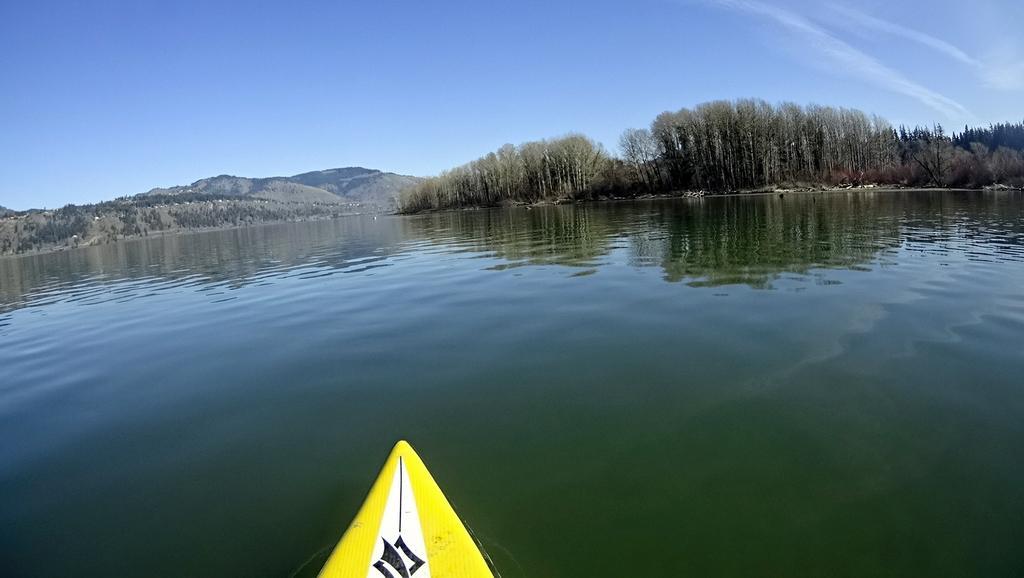Can you describe this image briefly? In this image we can see the partial part of the boat. And we can see the water. And we can see the mountain. And we can see the surrounding trees. And we can see the clouds in the sky. 